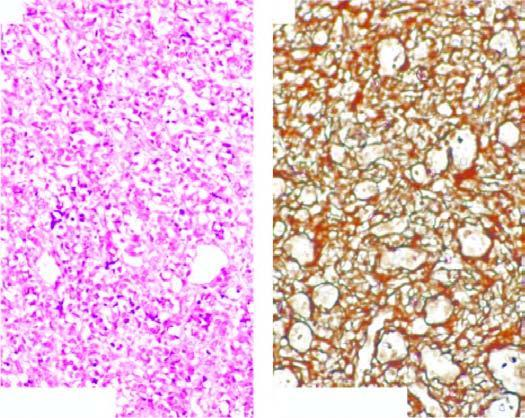re the vascular channels lined by multiple layers of plump endothelial cells having minimal mitotic activity obliterating the lumina?
Answer the question using a single word or phrase. Yes 